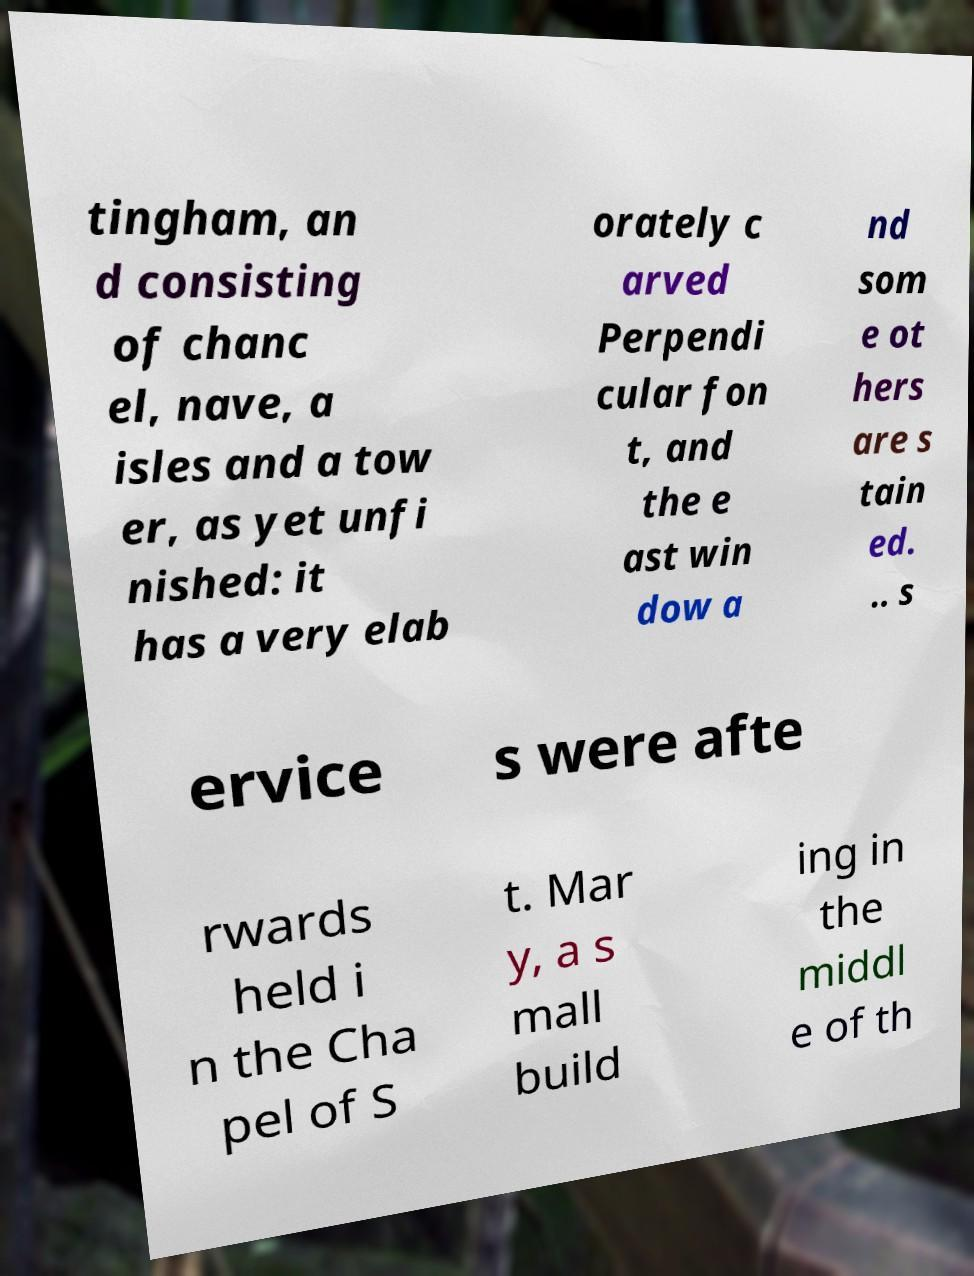Could you assist in decoding the text presented in this image and type it out clearly? tingham, an d consisting of chanc el, nave, a isles and a tow er, as yet unfi nished: it has a very elab orately c arved Perpendi cular fon t, and the e ast win dow a nd som e ot hers are s tain ed. .. s ervice s were afte rwards held i n the Cha pel of S t. Mar y, a s mall build ing in the middl e of th 